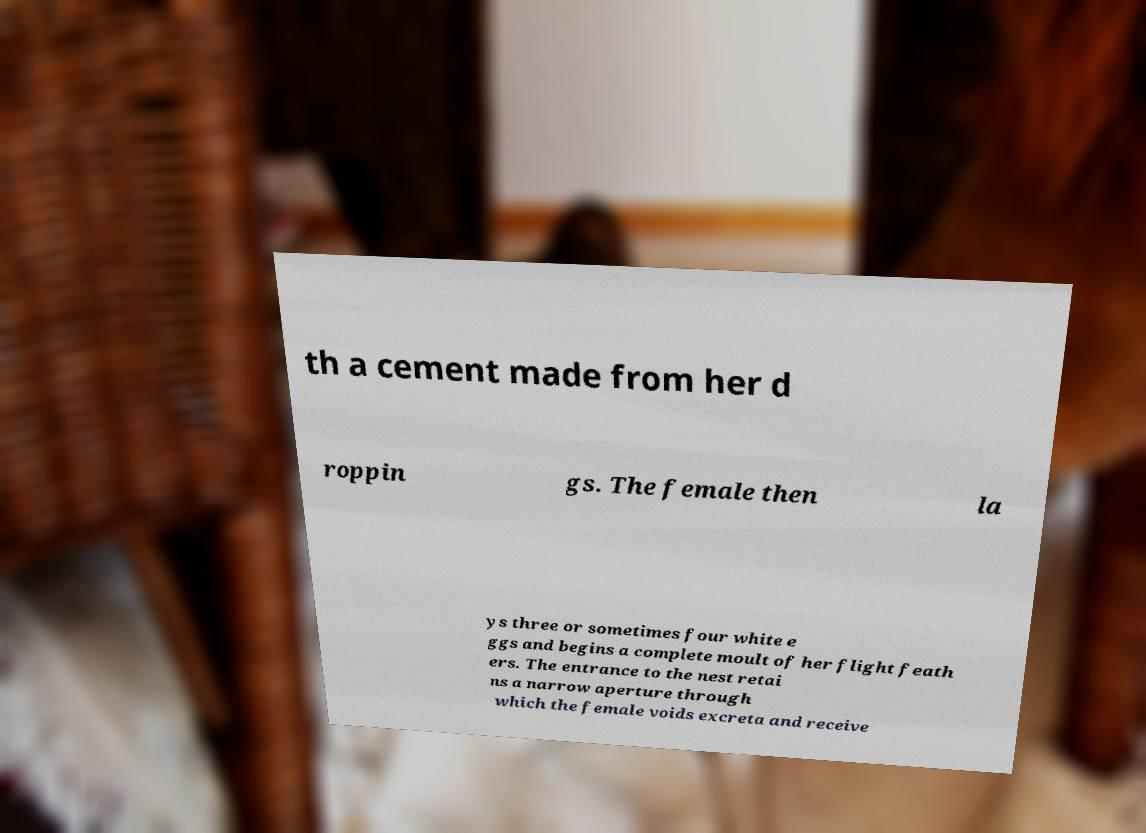Can you accurately transcribe the text from the provided image for me? th a cement made from her d roppin gs. The female then la ys three or sometimes four white e ggs and begins a complete moult of her flight feath ers. The entrance to the nest retai ns a narrow aperture through which the female voids excreta and receive 